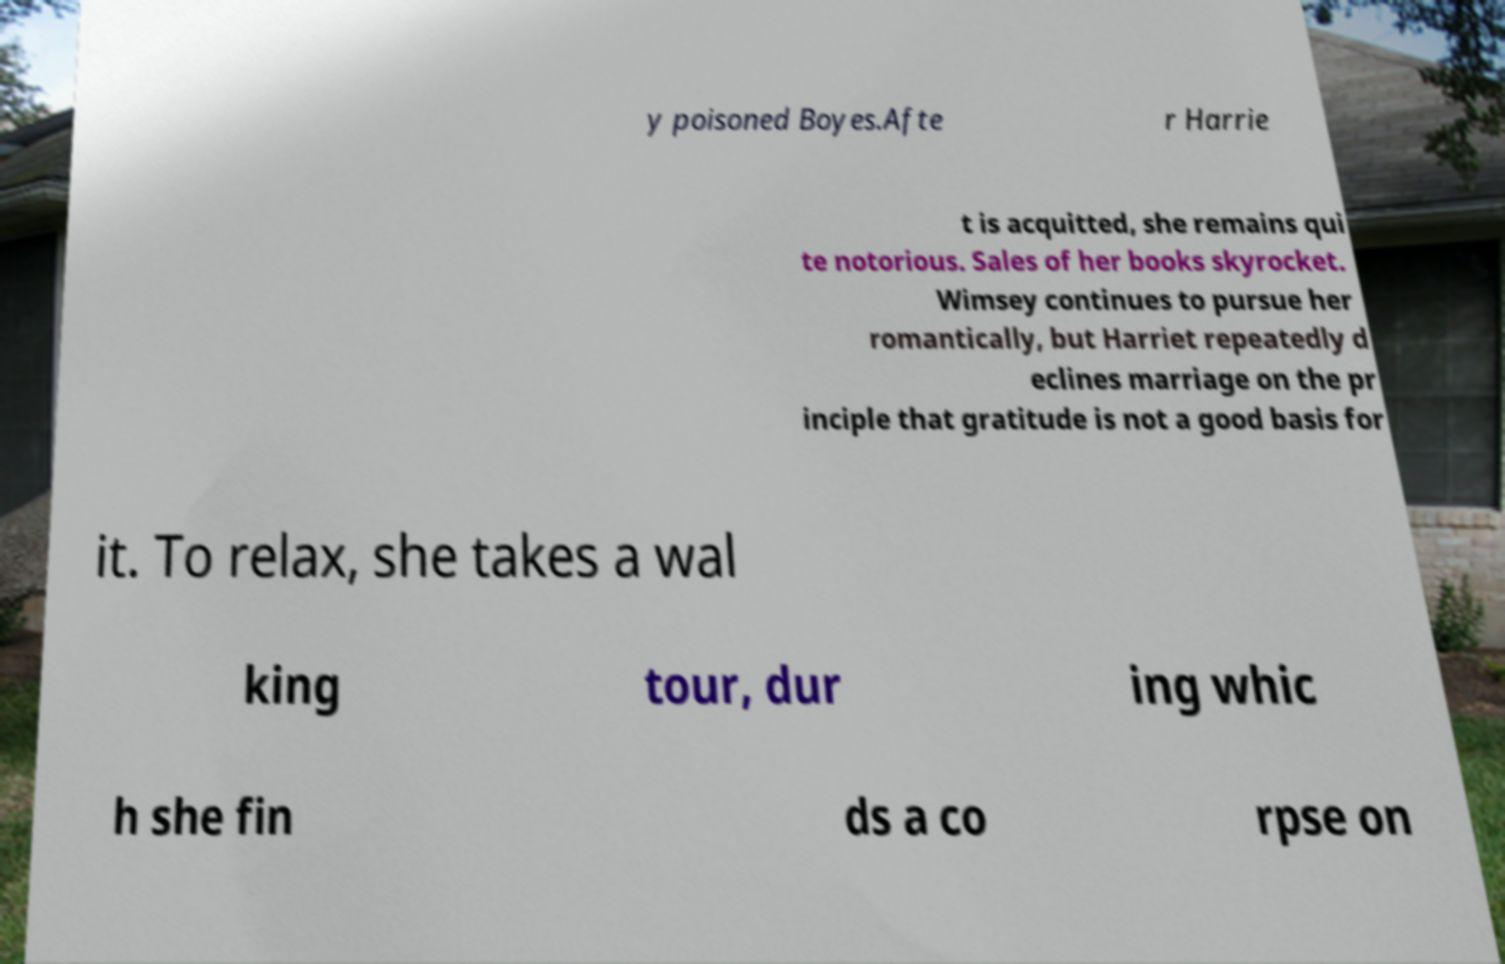Could you assist in decoding the text presented in this image and type it out clearly? y poisoned Boyes.Afte r Harrie t is acquitted, she remains qui te notorious. Sales of her books skyrocket. Wimsey continues to pursue her romantically, but Harriet repeatedly d eclines marriage on the pr inciple that gratitude is not a good basis for it. To relax, she takes a wal king tour, dur ing whic h she fin ds a co rpse on 